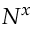<formula> <loc_0><loc_0><loc_500><loc_500>N ^ { x }</formula> 